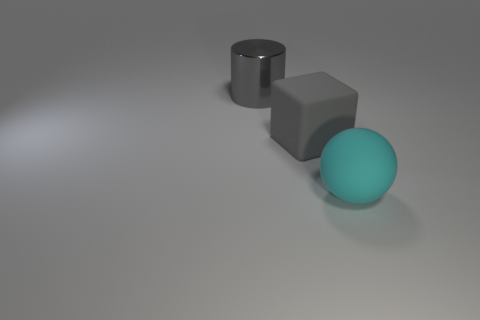What kind of lighting is used to illuminate these objects? The lighting in this image appears to be soft and diffuse, likely coming from a wide light source placed above the scene, as evidenced by the gentle shadows and lack of harsh highlights on the objects. 